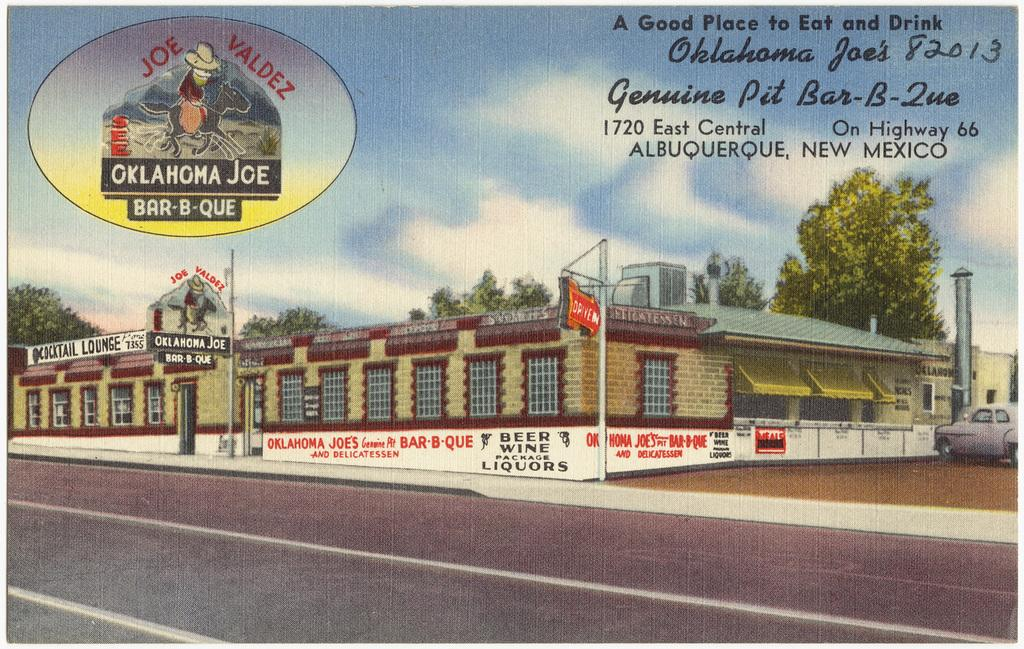What type of visual representation is the image? The image is a poster. What kind of structures can be seen in the poster? There are buildings with windows in the poster. What additional elements are present in the poster? Banners, a car, a road, trees, the sky with clouds, and some text are present in the poster. What type of relation is depicted between the car and the trees in the poster? There is no specific relation depicted between the car and the trees in the poster; they are simply present in the image. 